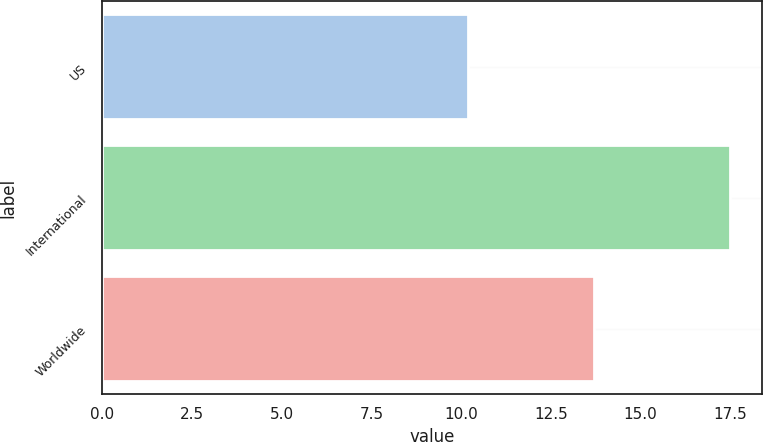Convert chart. <chart><loc_0><loc_0><loc_500><loc_500><bar_chart><fcel>US<fcel>International<fcel>Worldwide<nl><fcel>10.2<fcel>17.5<fcel>13.7<nl></chart> 